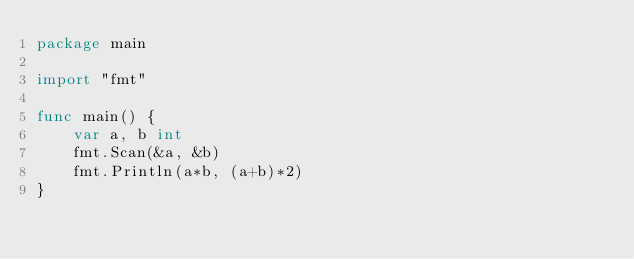<code> <loc_0><loc_0><loc_500><loc_500><_Go_>package main

import "fmt"

func main() {
	var a, b int
	fmt.Scan(&a, &b)
	fmt.Println(a*b, (a+b)*2)
}
</code> 